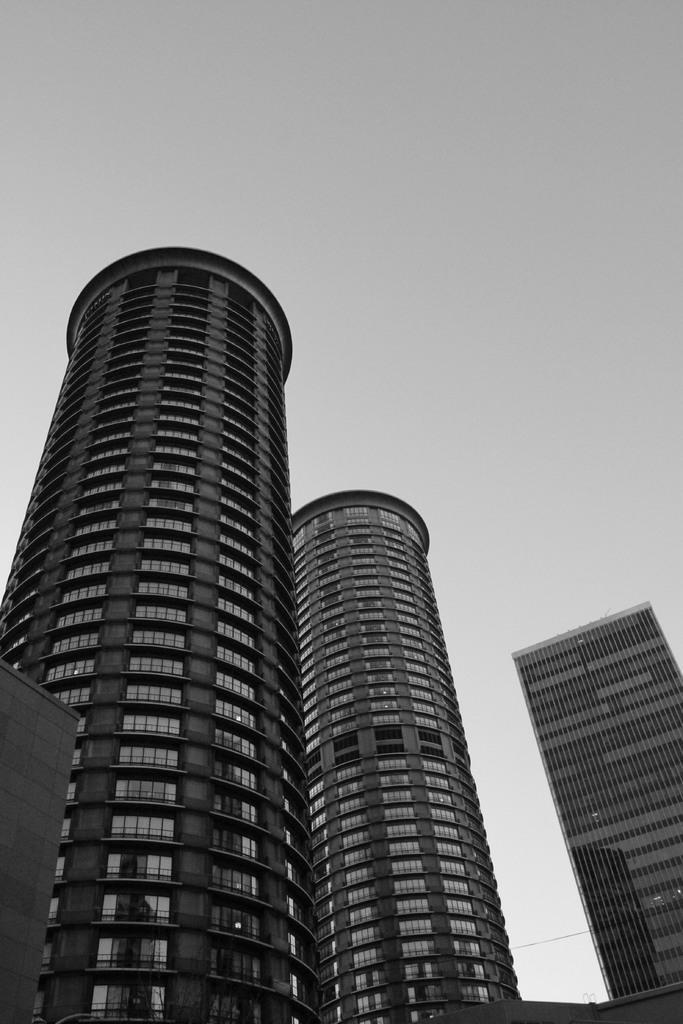Describe this image in one or two sentences. In this picture we can see buildings and in the background we can see sky. 